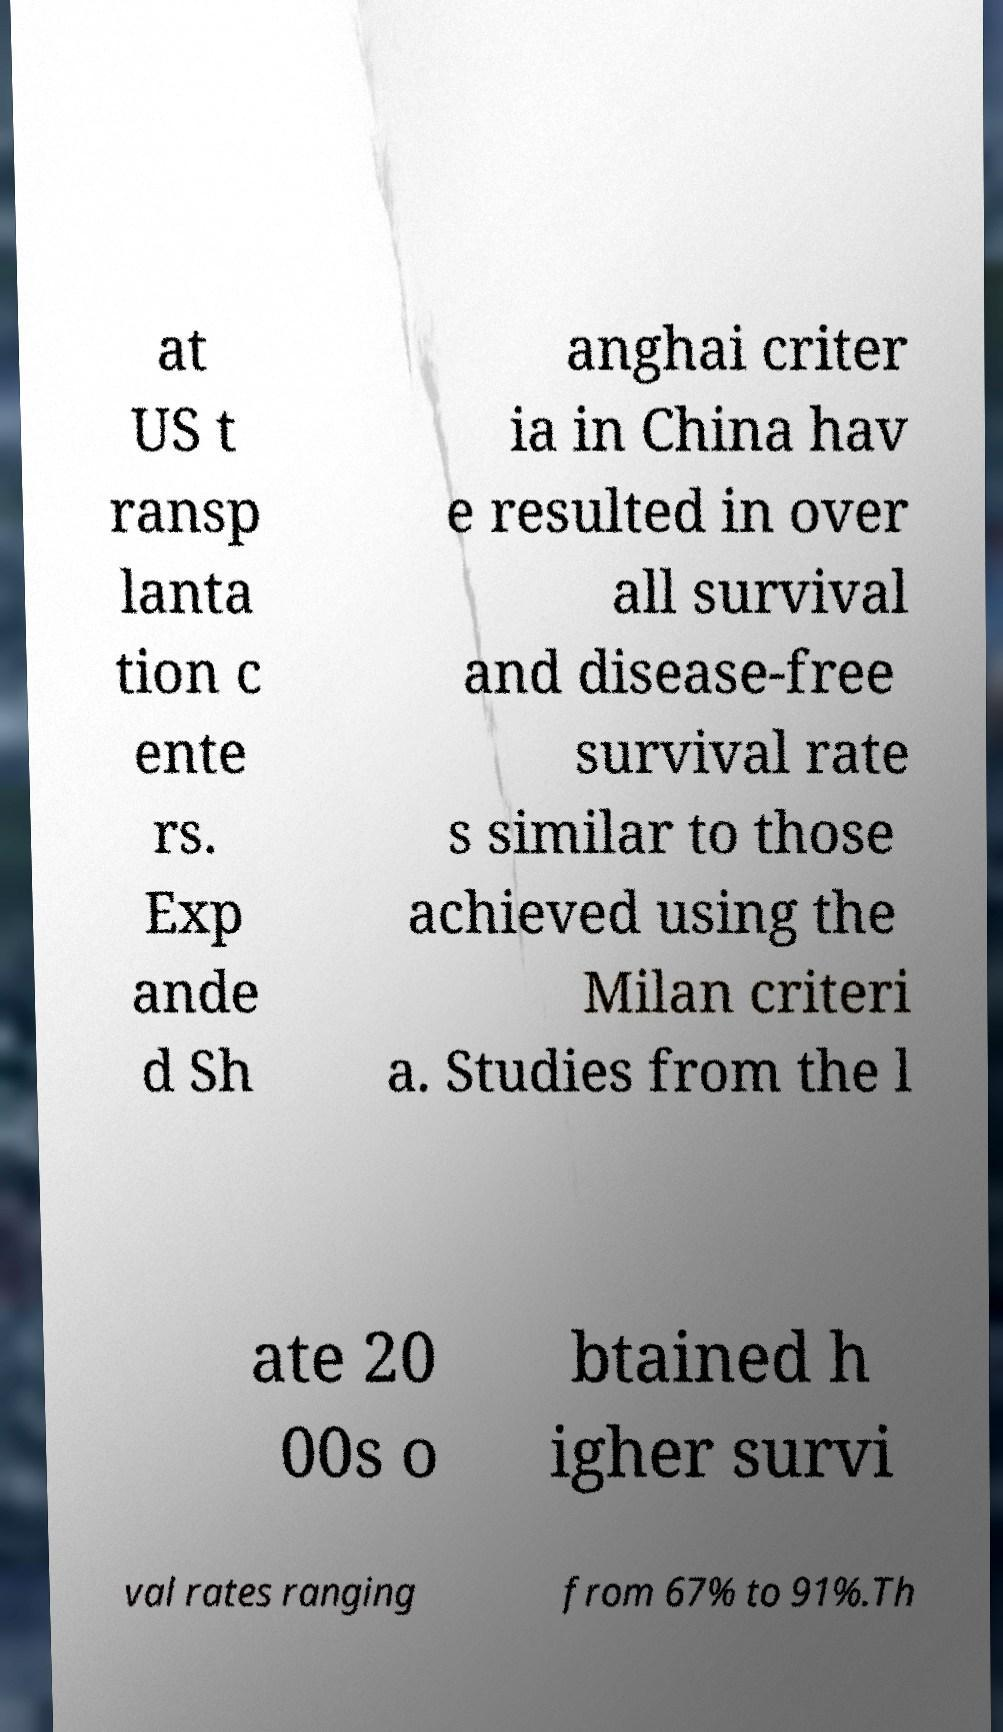Please identify and transcribe the text found in this image. at US t ransp lanta tion c ente rs. Exp ande d Sh anghai criter ia in China hav e resulted in over all survival and disease-free survival rate s similar to those achieved using the Milan criteri a. Studies from the l ate 20 00s o btained h igher survi val rates ranging from 67% to 91%.Th 